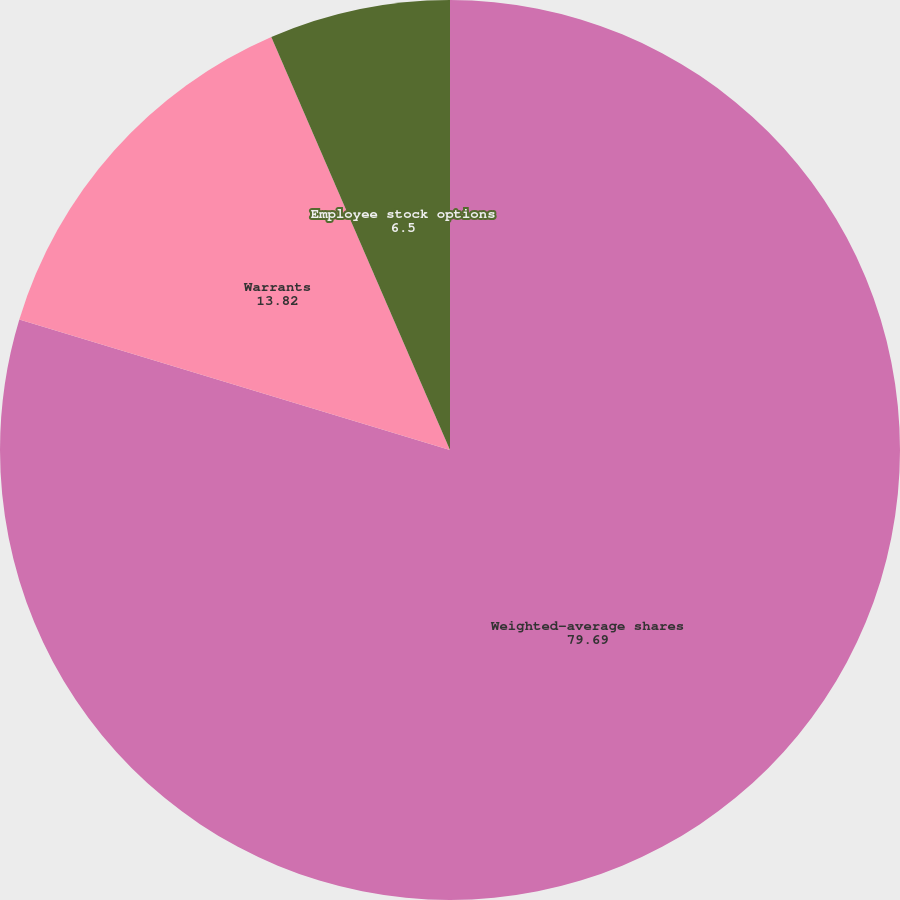Convert chart to OTSL. <chart><loc_0><loc_0><loc_500><loc_500><pie_chart><fcel>Weighted-average shares<fcel>Warrants<fcel>Employee stock options<nl><fcel>79.69%<fcel>13.82%<fcel>6.5%<nl></chart> 